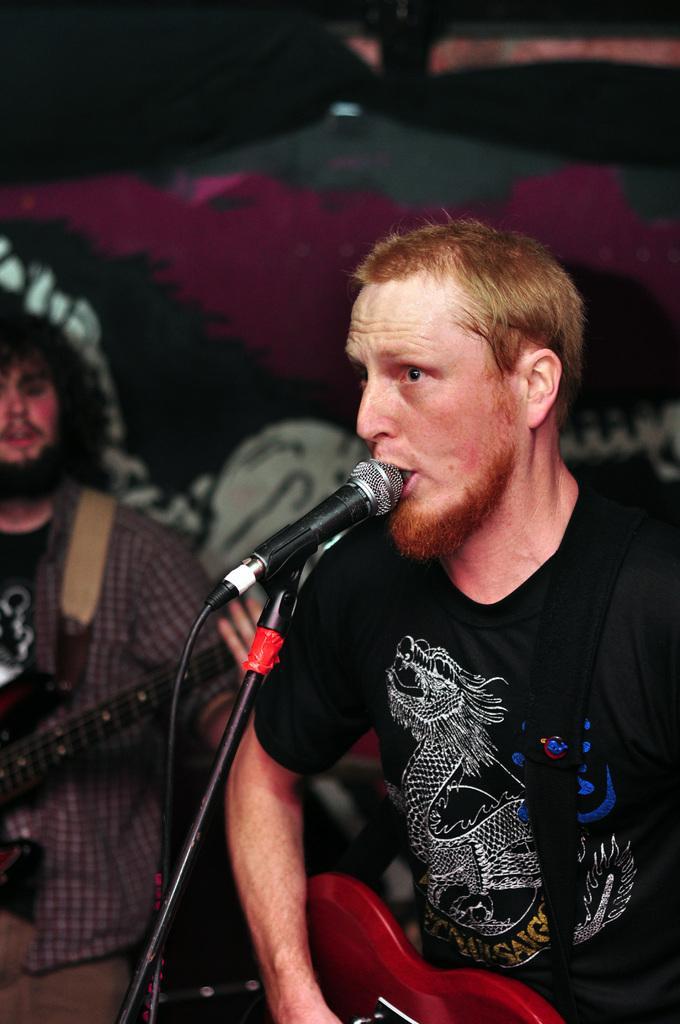How would you summarize this image in a sentence or two? In this image there is a person with black t-shirt, he is standing and playing guitar and he is singing, at the back there is a person standing and playing guitar. In the front there is a microphone. 